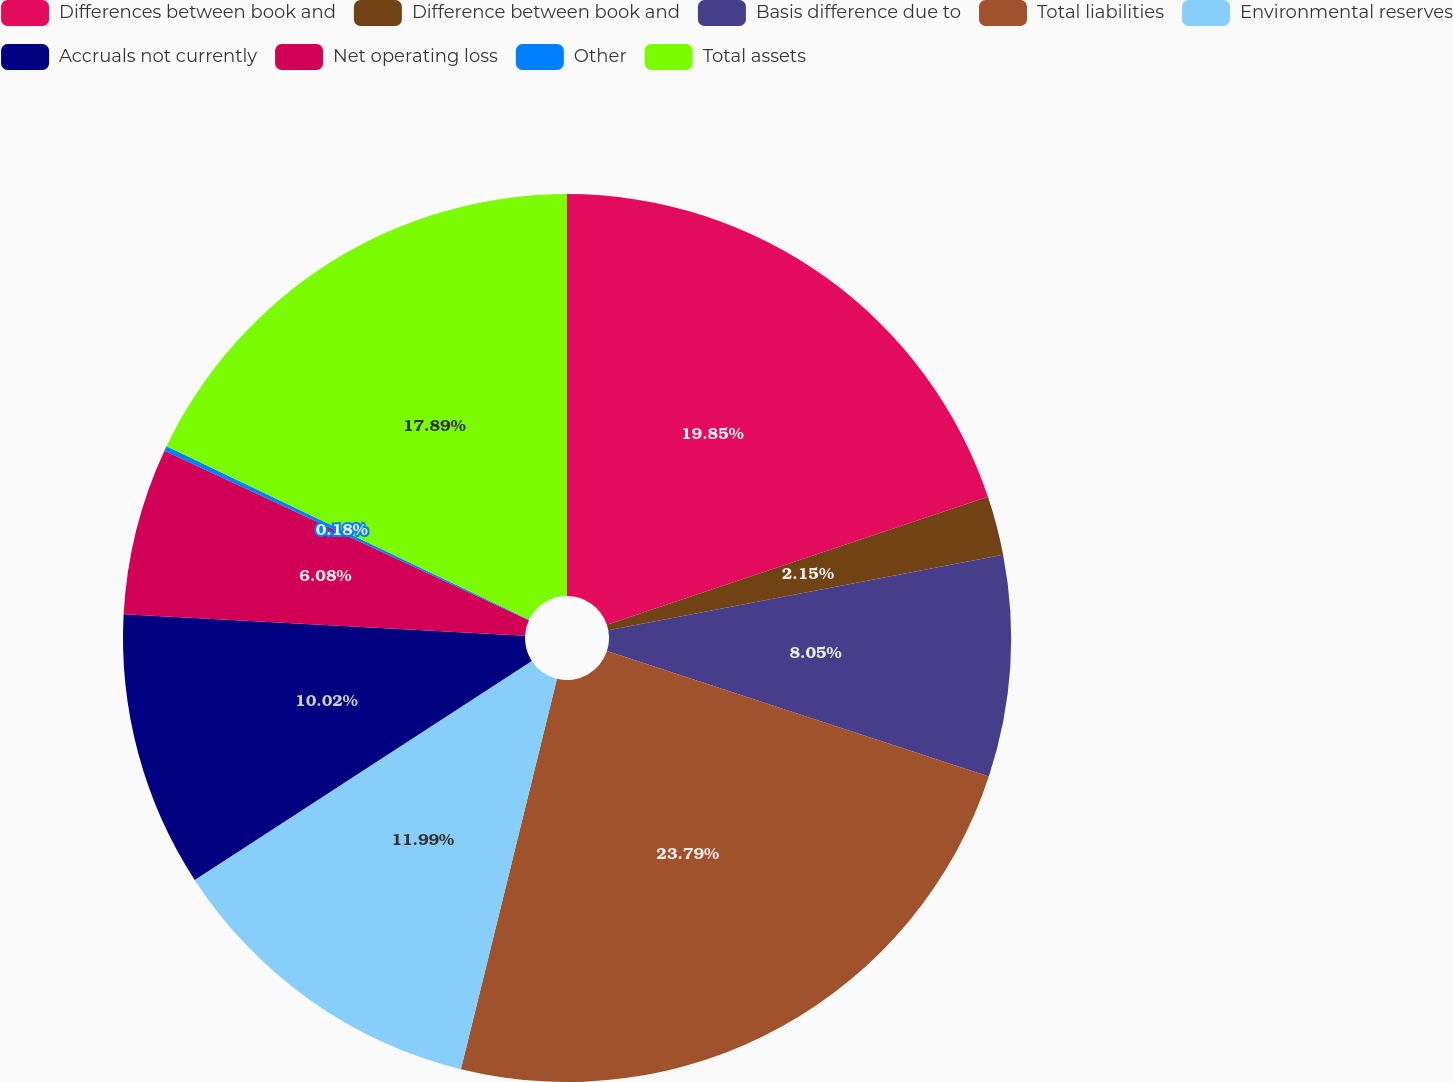Convert chart to OTSL. <chart><loc_0><loc_0><loc_500><loc_500><pie_chart><fcel>Differences between book and<fcel>Difference between book and<fcel>Basis difference due to<fcel>Total liabilities<fcel>Environmental reserves<fcel>Accruals not currently<fcel>Net operating loss<fcel>Other<fcel>Total assets<nl><fcel>19.85%<fcel>2.15%<fcel>8.05%<fcel>23.79%<fcel>11.99%<fcel>10.02%<fcel>6.08%<fcel>0.18%<fcel>17.89%<nl></chart> 